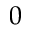<formula> <loc_0><loc_0><loc_500><loc_500>0</formula> 